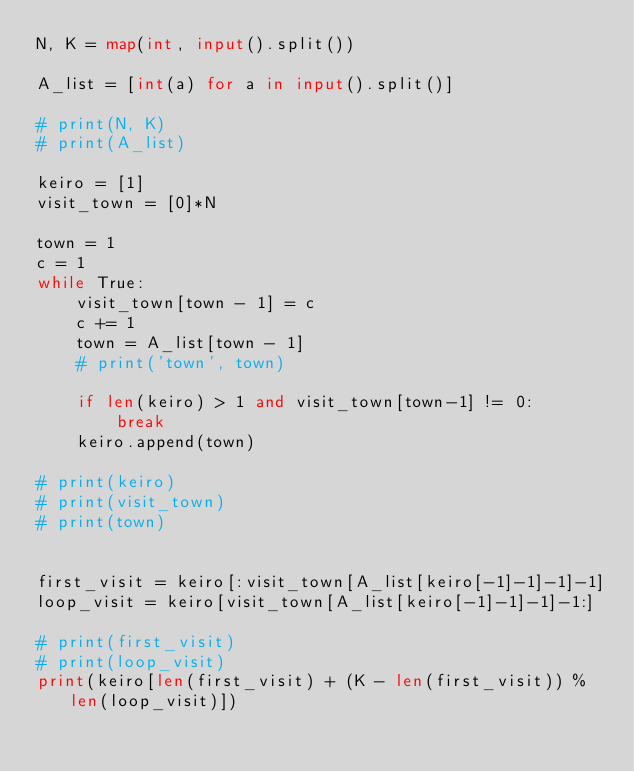<code> <loc_0><loc_0><loc_500><loc_500><_Python_>N, K = map(int, input().split())

A_list = [int(a) for a in input().split()]

# print(N, K)
# print(A_list)

keiro = [1]
visit_town = [0]*N

town = 1
c = 1
while True:
    visit_town[town - 1] = c
    c += 1
    town = A_list[town - 1]
    # print('town', town)

    if len(keiro) > 1 and visit_town[town-1] != 0:
        break
    keiro.append(town)

# print(keiro)
# print(visit_town)
# print(town)


first_visit = keiro[:visit_town[A_list[keiro[-1]-1]-1]-1]
loop_visit = keiro[visit_town[A_list[keiro[-1]-1]-1]-1:]

# print(first_visit)
# print(loop_visit)
print(keiro[len(first_visit) + (K - len(first_visit)) % len(loop_visit)])
</code> 